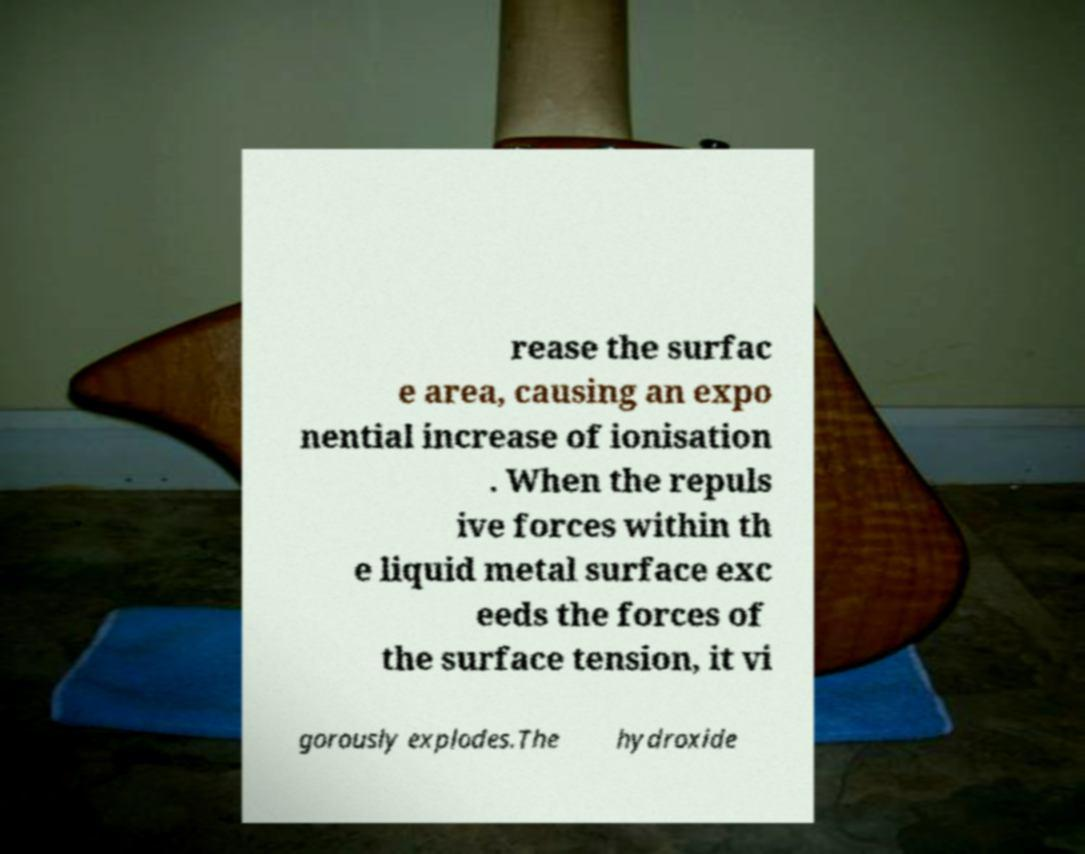Could you extract and type out the text from this image? rease the surfac e area, causing an expo nential increase of ionisation . When the repuls ive forces within th e liquid metal surface exc eeds the forces of the surface tension, it vi gorously explodes.The hydroxide 